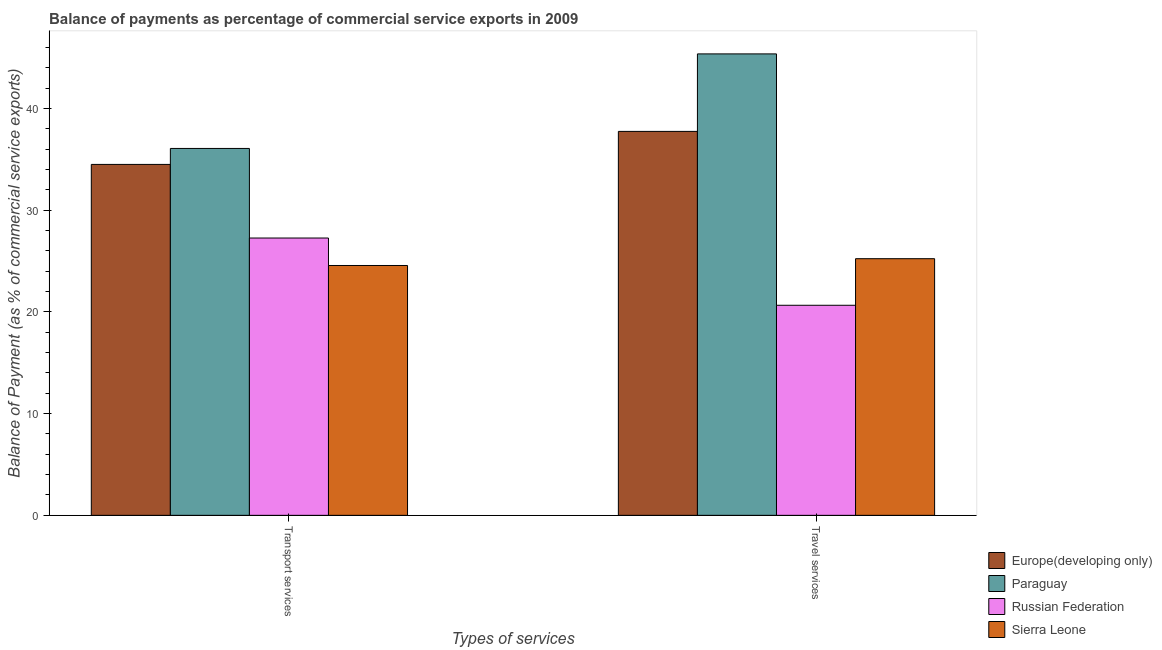How many groups of bars are there?
Your response must be concise. 2. Are the number of bars per tick equal to the number of legend labels?
Provide a succinct answer. Yes. Are the number of bars on each tick of the X-axis equal?
Offer a very short reply. Yes. How many bars are there on the 1st tick from the left?
Provide a short and direct response. 4. How many bars are there on the 1st tick from the right?
Your answer should be very brief. 4. What is the label of the 1st group of bars from the left?
Offer a very short reply. Transport services. What is the balance of payments of transport services in Sierra Leone?
Your answer should be compact. 24.56. Across all countries, what is the maximum balance of payments of travel services?
Make the answer very short. 45.36. Across all countries, what is the minimum balance of payments of transport services?
Your answer should be very brief. 24.56. In which country was the balance of payments of transport services maximum?
Make the answer very short. Paraguay. In which country was the balance of payments of transport services minimum?
Provide a succinct answer. Sierra Leone. What is the total balance of payments of travel services in the graph?
Your answer should be very brief. 128.98. What is the difference between the balance of payments of transport services in Russian Federation and that in Europe(developing only)?
Ensure brevity in your answer.  -7.24. What is the difference between the balance of payments of travel services in Russian Federation and the balance of payments of transport services in Paraguay?
Your response must be concise. -15.42. What is the average balance of payments of transport services per country?
Your answer should be compact. 30.6. What is the difference between the balance of payments of travel services and balance of payments of transport services in Europe(developing only)?
Offer a terse response. 3.25. In how many countries, is the balance of payments of travel services greater than 32 %?
Provide a short and direct response. 2. What is the ratio of the balance of payments of travel services in Europe(developing only) to that in Sierra Leone?
Keep it short and to the point. 1.5. Is the balance of payments of travel services in Russian Federation less than that in Paraguay?
Keep it short and to the point. Yes. What does the 2nd bar from the left in Travel services represents?
Offer a very short reply. Paraguay. What does the 4th bar from the right in Transport services represents?
Keep it short and to the point. Europe(developing only). How many bars are there?
Give a very brief answer. 8. Are all the bars in the graph horizontal?
Give a very brief answer. No. How many countries are there in the graph?
Provide a short and direct response. 4. Are the values on the major ticks of Y-axis written in scientific E-notation?
Offer a terse response. No. Where does the legend appear in the graph?
Your answer should be very brief. Bottom right. What is the title of the graph?
Your response must be concise. Balance of payments as percentage of commercial service exports in 2009. Does "Mauritius" appear as one of the legend labels in the graph?
Give a very brief answer. No. What is the label or title of the X-axis?
Offer a very short reply. Types of services. What is the label or title of the Y-axis?
Provide a succinct answer. Balance of Payment (as % of commercial service exports). What is the Balance of Payment (as % of commercial service exports) of Europe(developing only) in Transport services?
Keep it short and to the point. 34.5. What is the Balance of Payment (as % of commercial service exports) in Paraguay in Transport services?
Make the answer very short. 36.07. What is the Balance of Payment (as % of commercial service exports) of Russian Federation in Transport services?
Provide a short and direct response. 27.26. What is the Balance of Payment (as % of commercial service exports) of Sierra Leone in Transport services?
Your answer should be compact. 24.56. What is the Balance of Payment (as % of commercial service exports) of Europe(developing only) in Travel services?
Your answer should be very brief. 37.74. What is the Balance of Payment (as % of commercial service exports) of Paraguay in Travel services?
Offer a terse response. 45.36. What is the Balance of Payment (as % of commercial service exports) of Russian Federation in Travel services?
Your response must be concise. 20.65. What is the Balance of Payment (as % of commercial service exports) of Sierra Leone in Travel services?
Ensure brevity in your answer.  25.23. Across all Types of services, what is the maximum Balance of Payment (as % of commercial service exports) of Europe(developing only)?
Keep it short and to the point. 37.74. Across all Types of services, what is the maximum Balance of Payment (as % of commercial service exports) of Paraguay?
Keep it short and to the point. 45.36. Across all Types of services, what is the maximum Balance of Payment (as % of commercial service exports) in Russian Federation?
Provide a short and direct response. 27.26. Across all Types of services, what is the maximum Balance of Payment (as % of commercial service exports) in Sierra Leone?
Ensure brevity in your answer.  25.23. Across all Types of services, what is the minimum Balance of Payment (as % of commercial service exports) of Europe(developing only)?
Offer a terse response. 34.5. Across all Types of services, what is the minimum Balance of Payment (as % of commercial service exports) of Paraguay?
Ensure brevity in your answer.  36.07. Across all Types of services, what is the minimum Balance of Payment (as % of commercial service exports) of Russian Federation?
Provide a succinct answer. 20.65. Across all Types of services, what is the minimum Balance of Payment (as % of commercial service exports) of Sierra Leone?
Give a very brief answer. 24.56. What is the total Balance of Payment (as % of commercial service exports) of Europe(developing only) in the graph?
Your response must be concise. 72.24. What is the total Balance of Payment (as % of commercial service exports) of Paraguay in the graph?
Your response must be concise. 81.43. What is the total Balance of Payment (as % of commercial service exports) in Russian Federation in the graph?
Keep it short and to the point. 47.91. What is the total Balance of Payment (as % of commercial service exports) in Sierra Leone in the graph?
Offer a very short reply. 49.79. What is the difference between the Balance of Payment (as % of commercial service exports) of Europe(developing only) in Transport services and that in Travel services?
Make the answer very short. -3.25. What is the difference between the Balance of Payment (as % of commercial service exports) of Paraguay in Transport services and that in Travel services?
Your response must be concise. -9.29. What is the difference between the Balance of Payment (as % of commercial service exports) of Russian Federation in Transport services and that in Travel services?
Your response must be concise. 6.61. What is the difference between the Balance of Payment (as % of commercial service exports) of Sierra Leone in Transport services and that in Travel services?
Your response must be concise. -0.67. What is the difference between the Balance of Payment (as % of commercial service exports) of Europe(developing only) in Transport services and the Balance of Payment (as % of commercial service exports) of Paraguay in Travel services?
Offer a very short reply. -10.86. What is the difference between the Balance of Payment (as % of commercial service exports) of Europe(developing only) in Transport services and the Balance of Payment (as % of commercial service exports) of Russian Federation in Travel services?
Offer a very short reply. 13.85. What is the difference between the Balance of Payment (as % of commercial service exports) in Europe(developing only) in Transport services and the Balance of Payment (as % of commercial service exports) in Sierra Leone in Travel services?
Offer a very short reply. 9.27. What is the difference between the Balance of Payment (as % of commercial service exports) of Paraguay in Transport services and the Balance of Payment (as % of commercial service exports) of Russian Federation in Travel services?
Your answer should be compact. 15.42. What is the difference between the Balance of Payment (as % of commercial service exports) in Paraguay in Transport services and the Balance of Payment (as % of commercial service exports) in Sierra Leone in Travel services?
Provide a short and direct response. 10.84. What is the difference between the Balance of Payment (as % of commercial service exports) in Russian Federation in Transport services and the Balance of Payment (as % of commercial service exports) in Sierra Leone in Travel services?
Your response must be concise. 2.03. What is the average Balance of Payment (as % of commercial service exports) in Europe(developing only) per Types of services?
Provide a short and direct response. 36.12. What is the average Balance of Payment (as % of commercial service exports) of Paraguay per Types of services?
Ensure brevity in your answer.  40.71. What is the average Balance of Payment (as % of commercial service exports) of Russian Federation per Types of services?
Your response must be concise. 23.96. What is the average Balance of Payment (as % of commercial service exports) in Sierra Leone per Types of services?
Your answer should be very brief. 24.89. What is the difference between the Balance of Payment (as % of commercial service exports) in Europe(developing only) and Balance of Payment (as % of commercial service exports) in Paraguay in Transport services?
Provide a short and direct response. -1.57. What is the difference between the Balance of Payment (as % of commercial service exports) of Europe(developing only) and Balance of Payment (as % of commercial service exports) of Russian Federation in Transport services?
Offer a very short reply. 7.24. What is the difference between the Balance of Payment (as % of commercial service exports) of Europe(developing only) and Balance of Payment (as % of commercial service exports) of Sierra Leone in Transport services?
Your answer should be compact. 9.94. What is the difference between the Balance of Payment (as % of commercial service exports) in Paraguay and Balance of Payment (as % of commercial service exports) in Russian Federation in Transport services?
Make the answer very short. 8.81. What is the difference between the Balance of Payment (as % of commercial service exports) of Paraguay and Balance of Payment (as % of commercial service exports) of Sierra Leone in Transport services?
Give a very brief answer. 11.51. What is the difference between the Balance of Payment (as % of commercial service exports) in Russian Federation and Balance of Payment (as % of commercial service exports) in Sierra Leone in Transport services?
Your answer should be very brief. 2.7. What is the difference between the Balance of Payment (as % of commercial service exports) of Europe(developing only) and Balance of Payment (as % of commercial service exports) of Paraguay in Travel services?
Give a very brief answer. -7.62. What is the difference between the Balance of Payment (as % of commercial service exports) of Europe(developing only) and Balance of Payment (as % of commercial service exports) of Russian Federation in Travel services?
Offer a terse response. 17.09. What is the difference between the Balance of Payment (as % of commercial service exports) of Europe(developing only) and Balance of Payment (as % of commercial service exports) of Sierra Leone in Travel services?
Your answer should be compact. 12.51. What is the difference between the Balance of Payment (as % of commercial service exports) in Paraguay and Balance of Payment (as % of commercial service exports) in Russian Federation in Travel services?
Provide a short and direct response. 24.71. What is the difference between the Balance of Payment (as % of commercial service exports) in Paraguay and Balance of Payment (as % of commercial service exports) in Sierra Leone in Travel services?
Provide a short and direct response. 20.13. What is the difference between the Balance of Payment (as % of commercial service exports) of Russian Federation and Balance of Payment (as % of commercial service exports) of Sierra Leone in Travel services?
Your answer should be very brief. -4.58. What is the ratio of the Balance of Payment (as % of commercial service exports) of Europe(developing only) in Transport services to that in Travel services?
Provide a short and direct response. 0.91. What is the ratio of the Balance of Payment (as % of commercial service exports) in Paraguay in Transport services to that in Travel services?
Give a very brief answer. 0.8. What is the ratio of the Balance of Payment (as % of commercial service exports) in Russian Federation in Transport services to that in Travel services?
Keep it short and to the point. 1.32. What is the ratio of the Balance of Payment (as % of commercial service exports) in Sierra Leone in Transport services to that in Travel services?
Make the answer very short. 0.97. What is the difference between the highest and the second highest Balance of Payment (as % of commercial service exports) of Europe(developing only)?
Make the answer very short. 3.25. What is the difference between the highest and the second highest Balance of Payment (as % of commercial service exports) of Paraguay?
Make the answer very short. 9.29. What is the difference between the highest and the second highest Balance of Payment (as % of commercial service exports) in Russian Federation?
Ensure brevity in your answer.  6.61. What is the difference between the highest and the second highest Balance of Payment (as % of commercial service exports) of Sierra Leone?
Give a very brief answer. 0.67. What is the difference between the highest and the lowest Balance of Payment (as % of commercial service exports) of Europe(developing only)?
Provide a short and direct response. 3.25. What is the difference between the highest and the lowest Balance of Payment (as % of commercial service exports) of Paraguay?
Your answer should be compact. 9.29. What is the difference between the highest and the lowest Balance of Payment (as % of commercial service exports) in Russian Federation?
Give a very brief answer. 6.61. What is the difference between the highest and the lowest Balance of Payment (as % of commercial service exports) of Sierra Leone?
Offer a terse response. 0.67. 